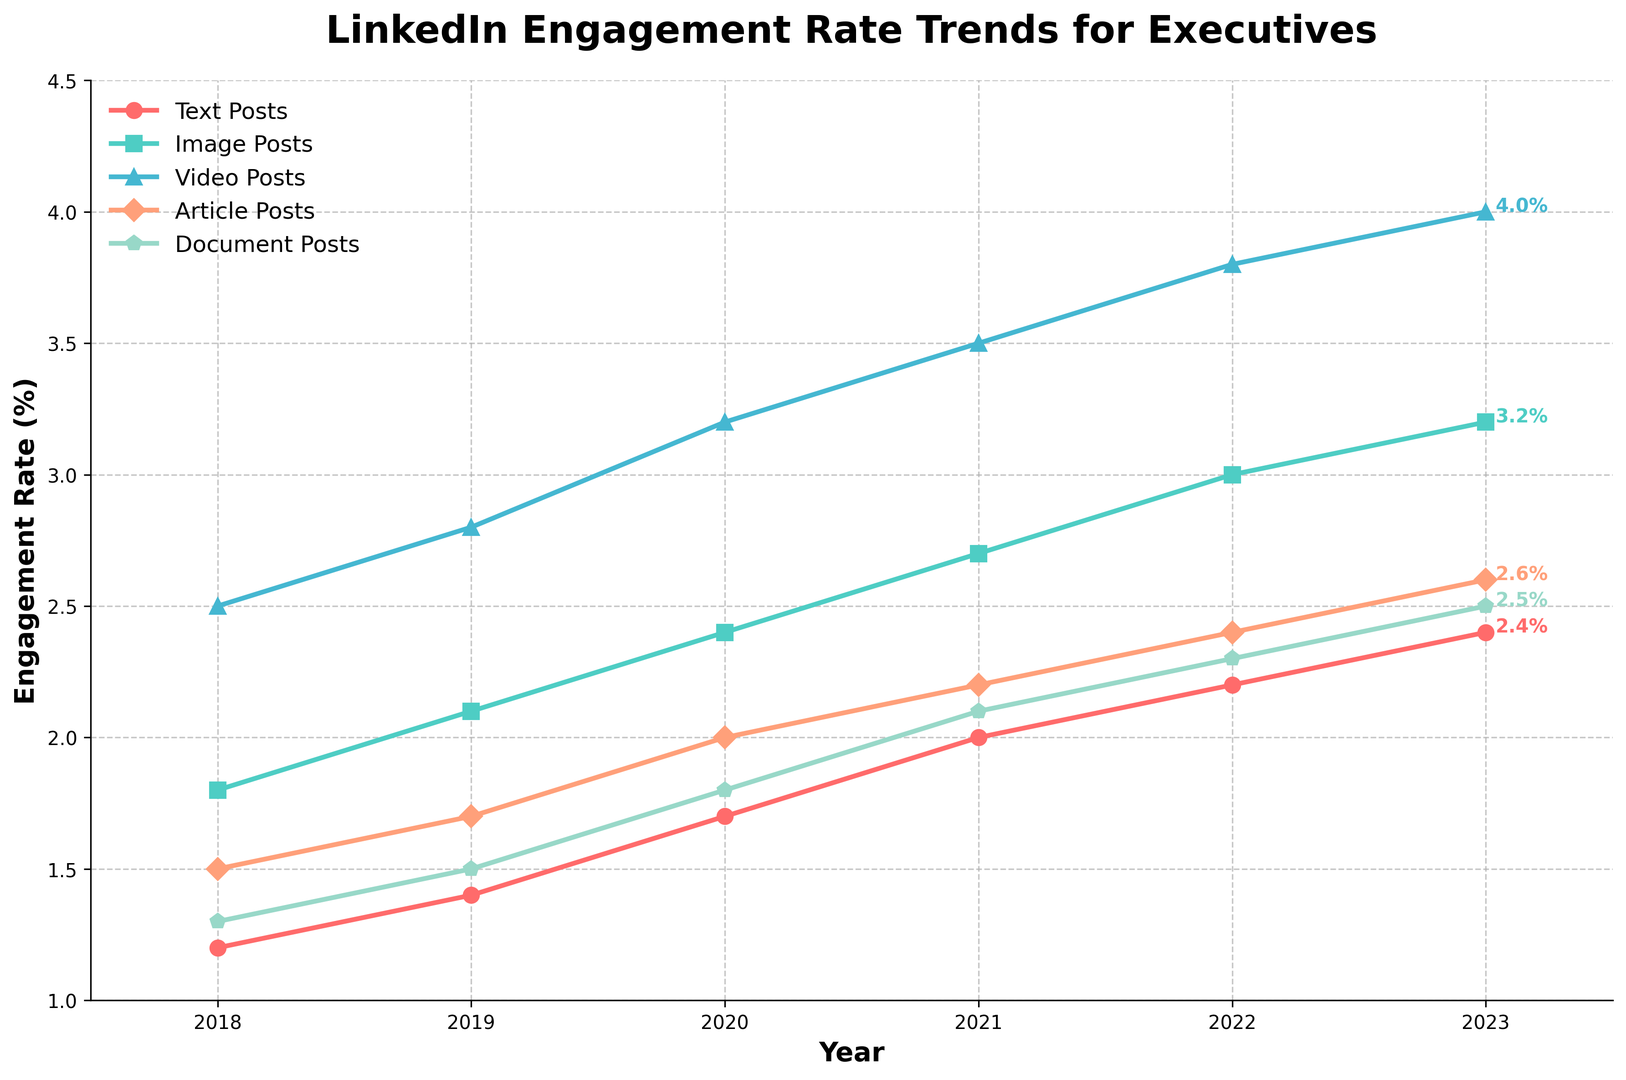Which content type had the highest engagement rate in 2023? Look at the rightmost point on the plot for each content type; the highest engagement rate will be at the top. The Video Posts line is the highest in 2023.
Answer: Video Posts How much did the engagement rate for Image Posts increase from 2018 to 2023? Identify the values for Image Posts in 2018 (1.8%) and 2023 (3.2%). Subtract the 2018 value from the 2023 value: 3.2% - 1.8% = 1.4%.
Answer: 1.4% What is the difference in engagement rate between Video Posts and Text Posts in 2023? Check the engagement rates for Video Posts (4.0%) and Text Posts (2.4%) in 2023 and subtract the value for Text Posts from Video Posts: 4.0% - 2.4% = 1.6%.
Answer: 1.6% Which content type had the slowest growth in engagement rate from 2018 to 2023? Calculate the difference in engagement rates for all content types between 2018 and 2023. The smallest difference indicates the slowest growth: Text Posts (2.4% - 1.2% = 1.2%), Image Posts (3.2% - 1.8% = 1.4%), Video Posts (4.0% - 2.5% = 1.5%), Article Posts (2.6% - 1.5% = 1.1%), Document Posts (2.5% - 1.3% = 1.2%). Article Posts have the slowest growth.
Answer: Article Posts On average, how much did the engagement rate of Document Posts increase per year from 2018 to 2023? Calculate the total increase for Document Posts: 2.5% in 2023 - 1.3% in 2018 = 1.2%. Divide by the number of years (2023-2018 = 5 years): 1.2% / 5 = 0.24%.
Answer: 0.24% Are there any years where the engagement rate of Article Posts remained the same as the previous year? Examine the points for Article Posts year by year. Ensure there is no repeated value when moving from one year to the next.
Answer: No Which content type saw the highest increase in engagement rate between 2019 and 2020? Calculate the difference in engagement rates from 2019 to 2020 for each type: Text Posts (1.7% - 1.4% = 0.3%), Image Posts (2.4% - 2.1% = 0.3%), Video Posts (3.2% - 2.8% = 0.4%), Article Posts (2.0% - 1.7% = 0.3%), Document Posts (1.8% - 1.5% = 0.3%). Video Posts have the highest increase.
Answer: Video Posts What was the engagement rate for Article Posts in 2021, and how does it compare to the engagement rate for Text Posts in the same year? Find the value for Article Posts in 2021 (2.2%) and Text Posts in 2021 (2.0%). Article Posts have a slightly higher engagement rate in 2021.
Answer: 2.2%, Higher Between which two consecutive years did Text Posts see the largest percentage point increase in engagement rate? Check the year-to-year differences for Text Posts: 2018-2019 (1.4% - 1.2% = 0.2%), 2019-2020 (1.7% - 1.4% = 0.3%), 2020-2021 (2.0% - 1.7% = 0.3%), 2021-2022 (2.2% - 2.0% = 0.2%), 2022-2023 (2.4% - 2.2% = 0.2%). The largest increase is between 2019 and 2020, and between 2020 and 2021 (0.3 percentage points each).
Answer: 2019-2020 and 2020-2021 Which year did Image Posts surpass the 2.0% engagement rate? Identify the year where Image Posts engagement rate first exceeded 2.0%. This occurred in 2019.
Answer: 2019 